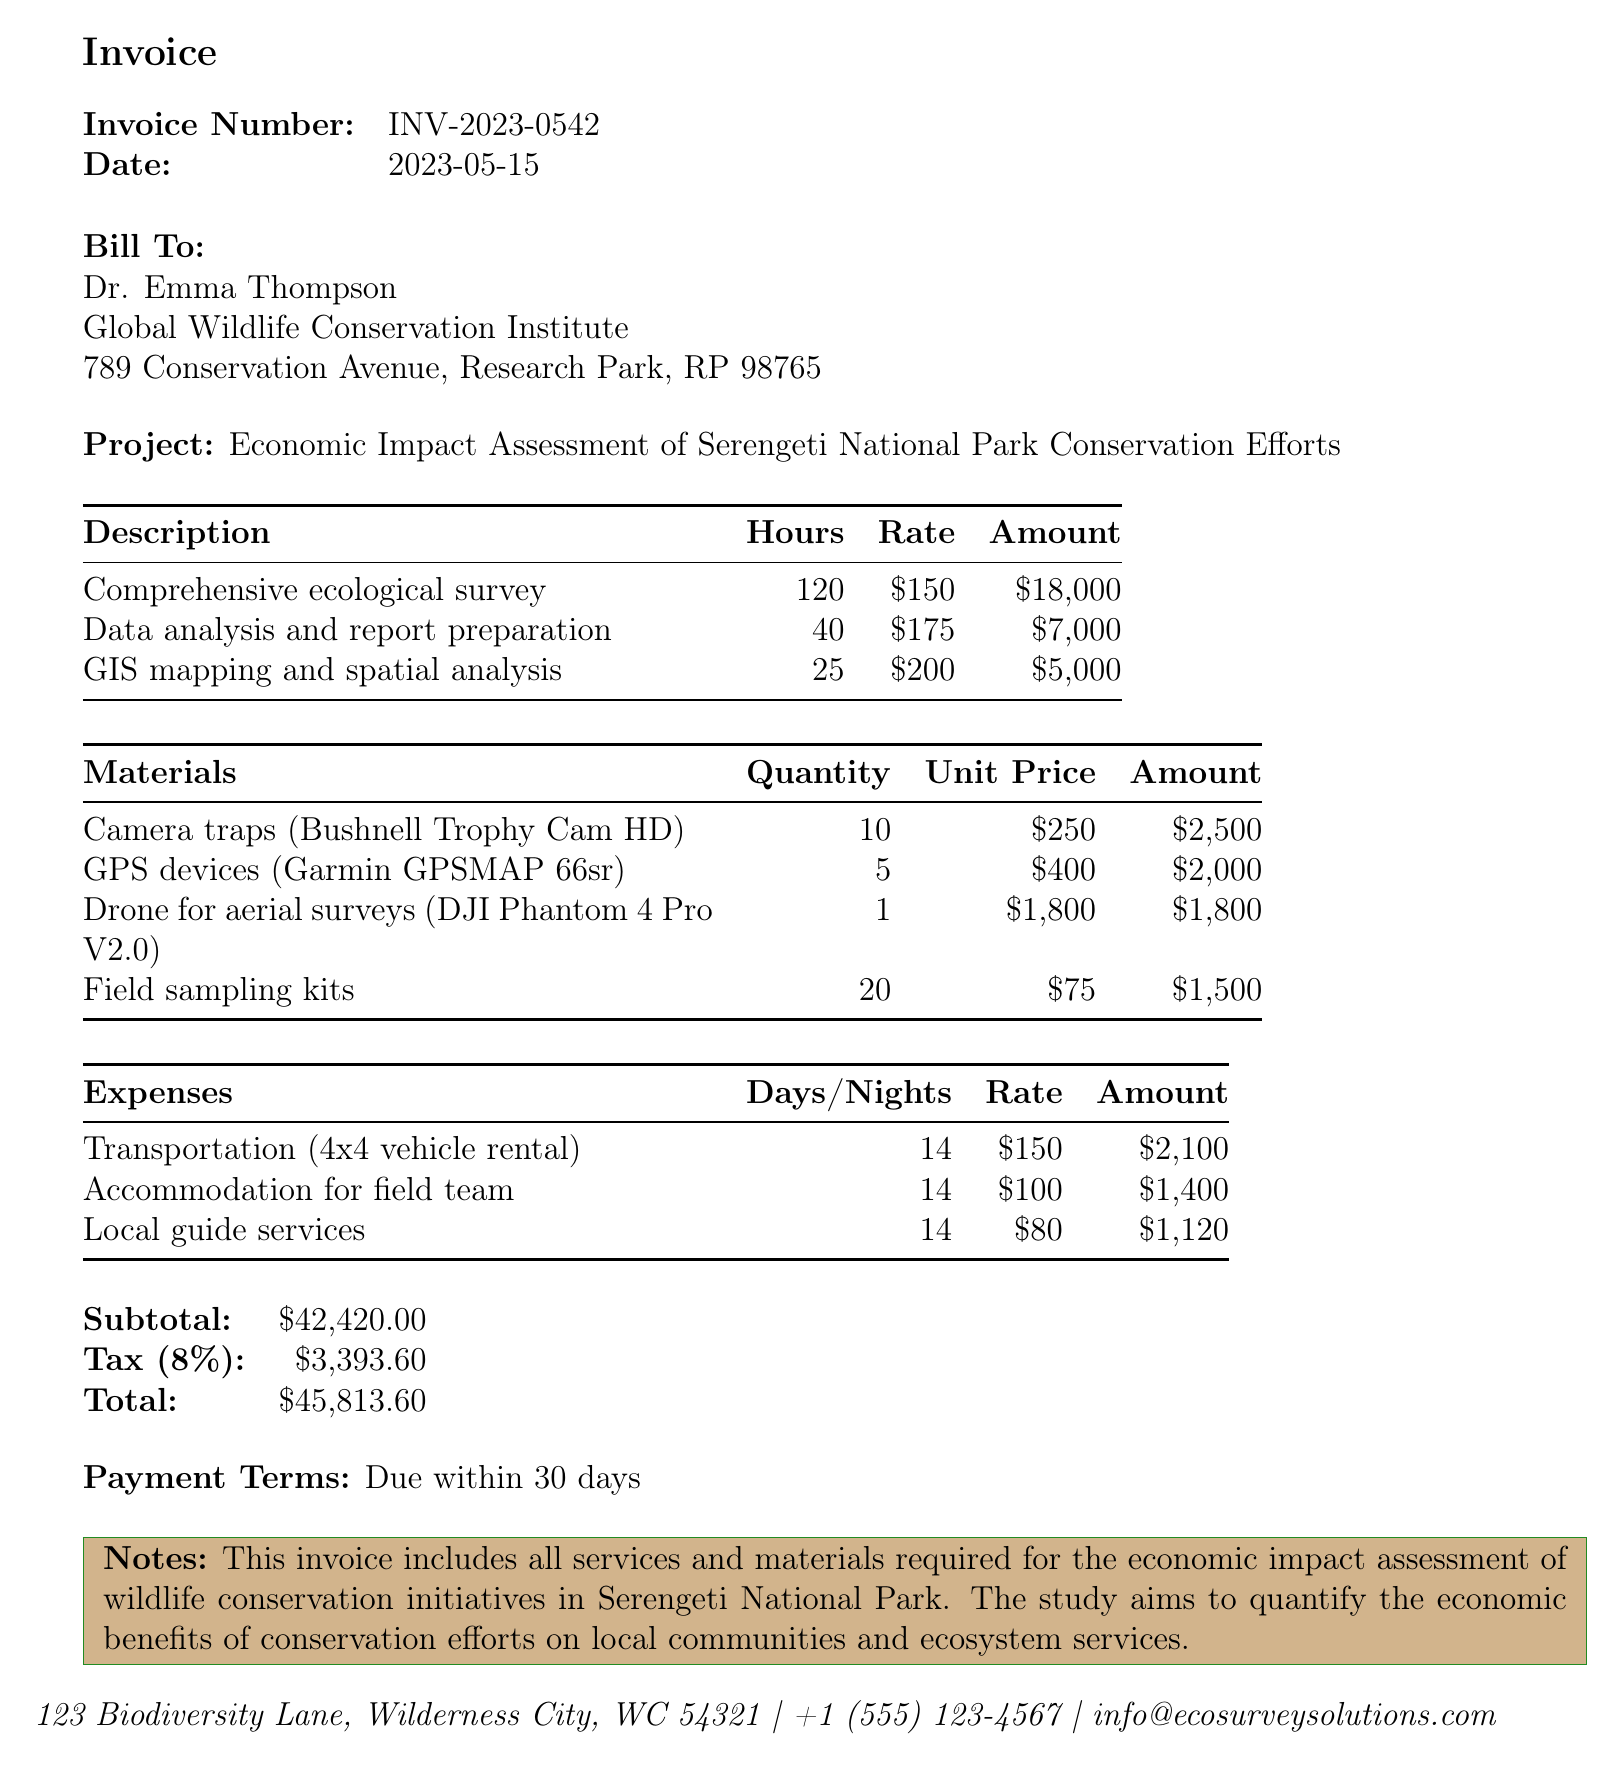what is the invoice number? The invoice number is specified in the document to uniquely identify the transaction, which is INV-2023-0542.
Answer: INV-2023-0542 who is the recipient of the invoice? The recipient, or the client billed, is Dr. Emma Thompson, mentioned in the "Bill To" section.
Answer: Dr. Emma Thompson what is the total amount due? The total amount due is the final figure that combines all services, materials, and applicable taxes, which is $45,813.60.
Answer: $45,813.60 how many hours were spent on data analysis and report preparation? The number of hours spent on data analysis and report preparation is listed explicitly under services, which is 40 hours.
Answer: 40 what is the subtotal before tax? The subtotal is the total of all services and materials listed before any taxes are added, which is $42,420.
Answer: $42,420 what is the tax rate applied in this invoice? The tax rate is indicated in the document as a specific percentage of the subtotal, which is 8%.
Answer: 8% what materials were used for the ecological survey? The document lists specific materials required for the survey, including camera traps, GPS devices, a drone, and field sampling kits.
Answer: Camera traps, GPS devices, Drone, Field sampling kits how many nights of accommodation were provided for the field team? The number of nights stayed for the accommodation of the field team is clearly stated in the expenses section, which is 14 nights.
Answer: 14 what project is being assessed in this invoice? The project being assessed, as mentioned in the "Project" label, focuses on the economic impact assessment related to conservation efforts in a specific national park.
Answer: Economic Impact Assessment of Serengeti National Park Conservation Efforts 